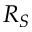<formula> <loc_0><loc_0><loc_500><loc_500>R _ { S }</formula> 